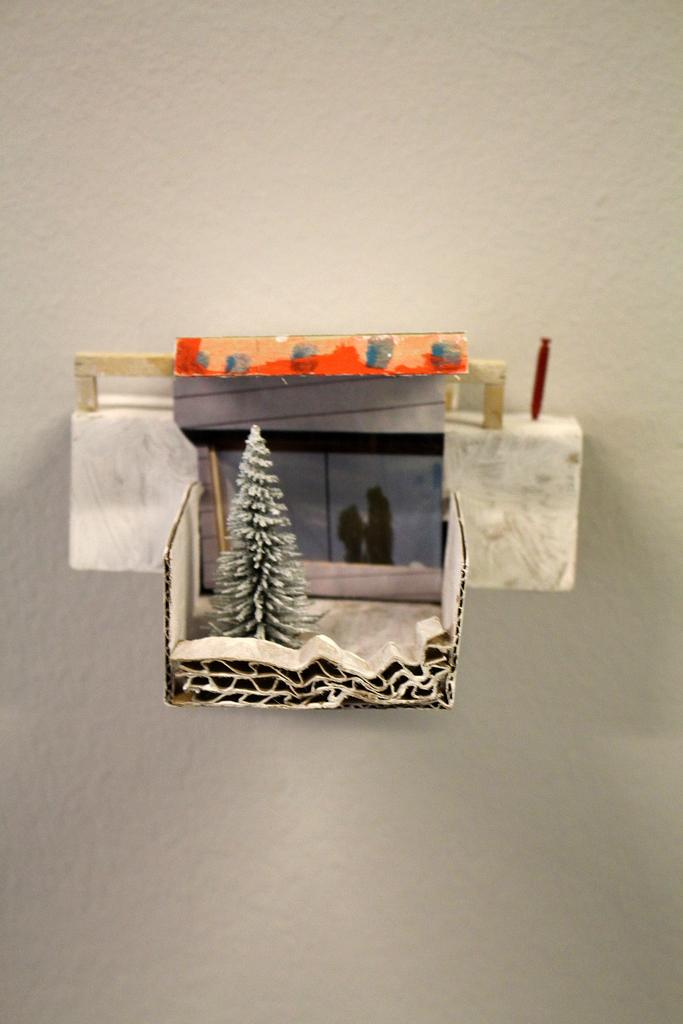What type of object can be seen in the image? There is a toy in the image. What else is present in the image? There is a photograph in the image. Where are the toy and the photograph located? Both the toy and the photograph are in a box. What can be seen on the wall in the image? There is an object on the wall in the image. How does the wind affect the toy and the photograph in the image? There is no wind present in the image, as both the toy and the photograph are in a box and not exposed to the elements. 